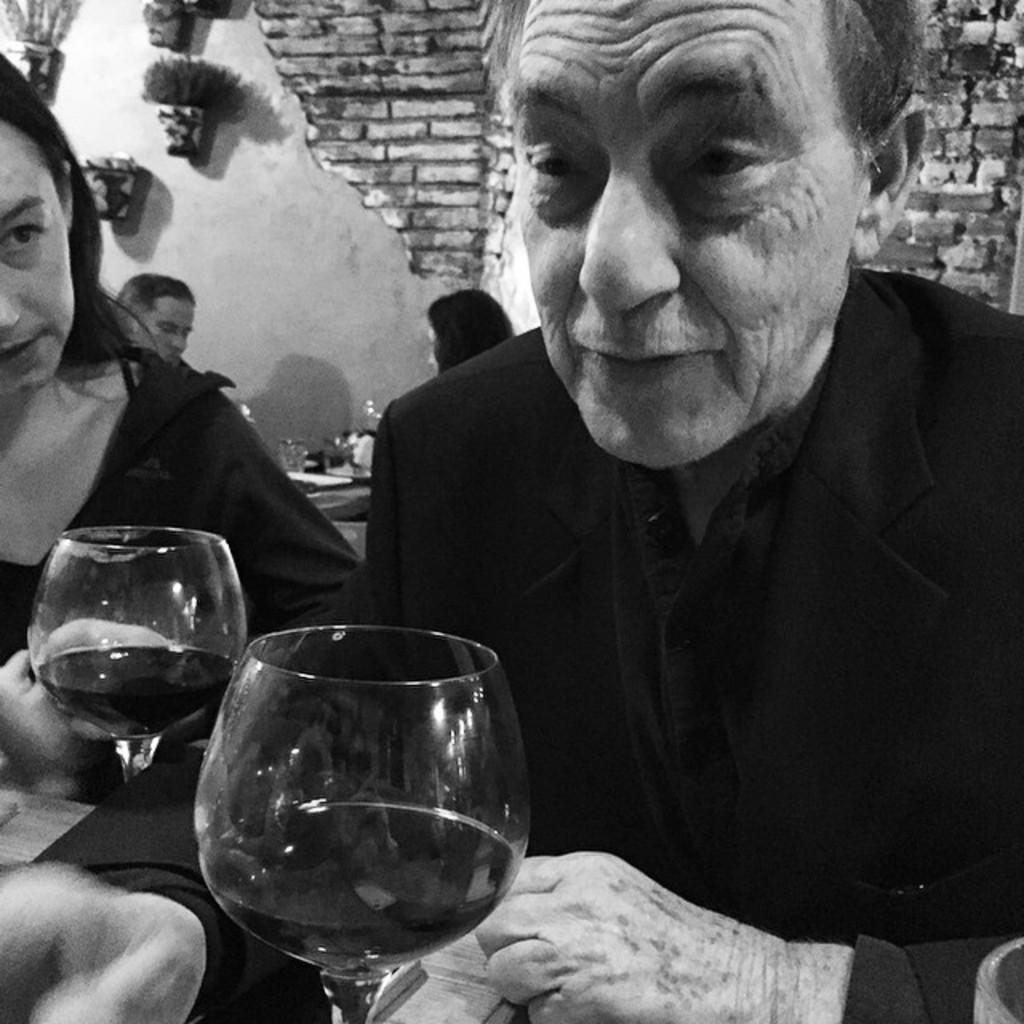How many people are present in the image? There are two people in the image, a man and a woman. What are the man and woman holding in the image? Both the man and woman are holding a wine glass. What can be seen in the background of the image? There are show plants attached to the wall in the background. Where are the two persons sitting in the image? They are sitting near a table in the image. What type of disease can be seen spreading among the plants in the image? There is no disease visible among the plants in the image, as it only shows a man, a woman, and show plants attached to the wall. 